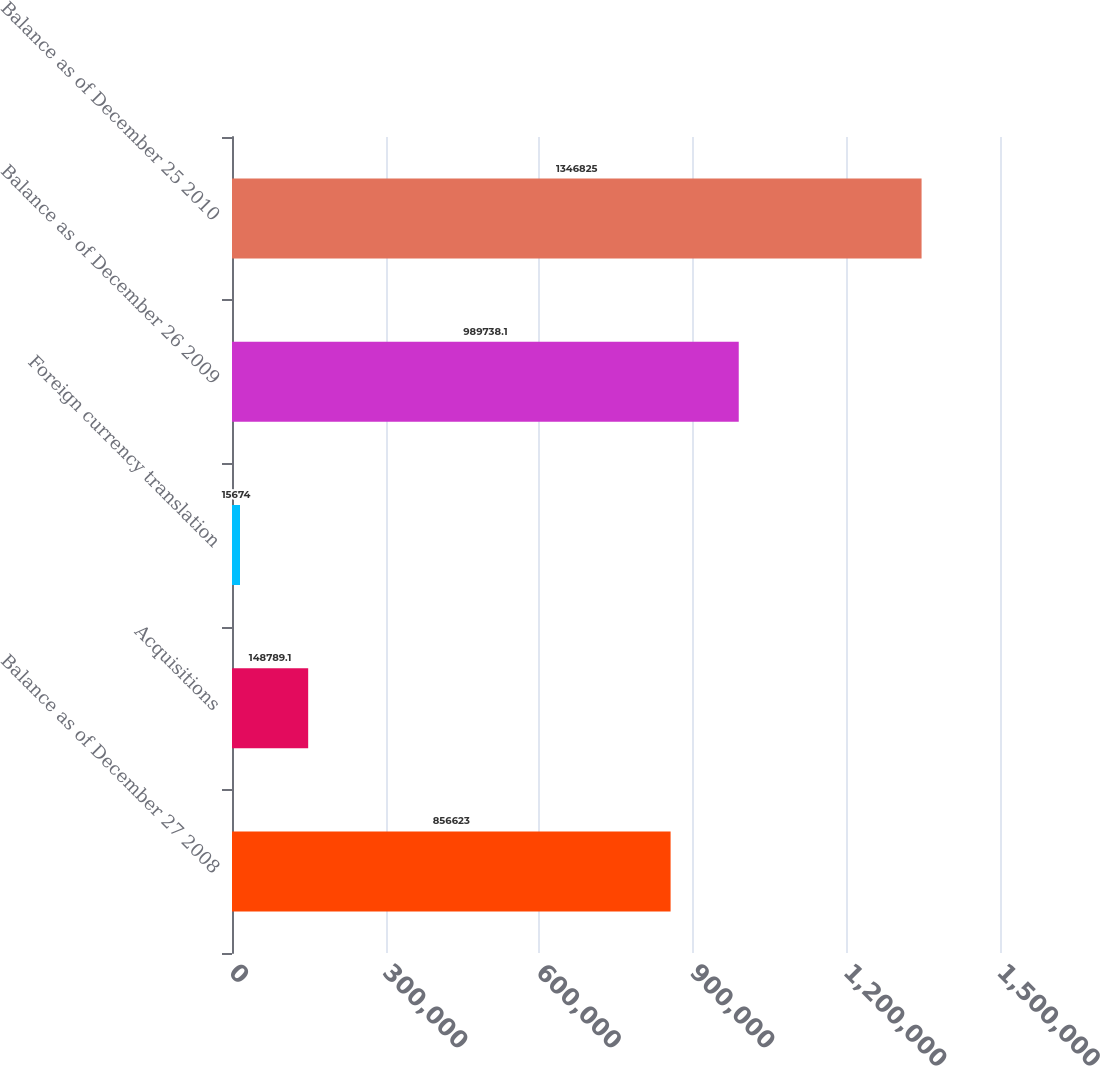Convert chart to OTSL. <chart><loc_0><loc_0><loc_500><loc_500><bar_chart><fcel>Balance as of December 27 2008<fcel>Acquisitions<fcel>Foreign currency translation<fcel>Balance as of December 26 2009<fcel>Balance as of December 25 2010<nl><fcel>856623<fcel>148789<fcel>15674<fcel>989738<fcel>1.34682e+06<nl></chart> 